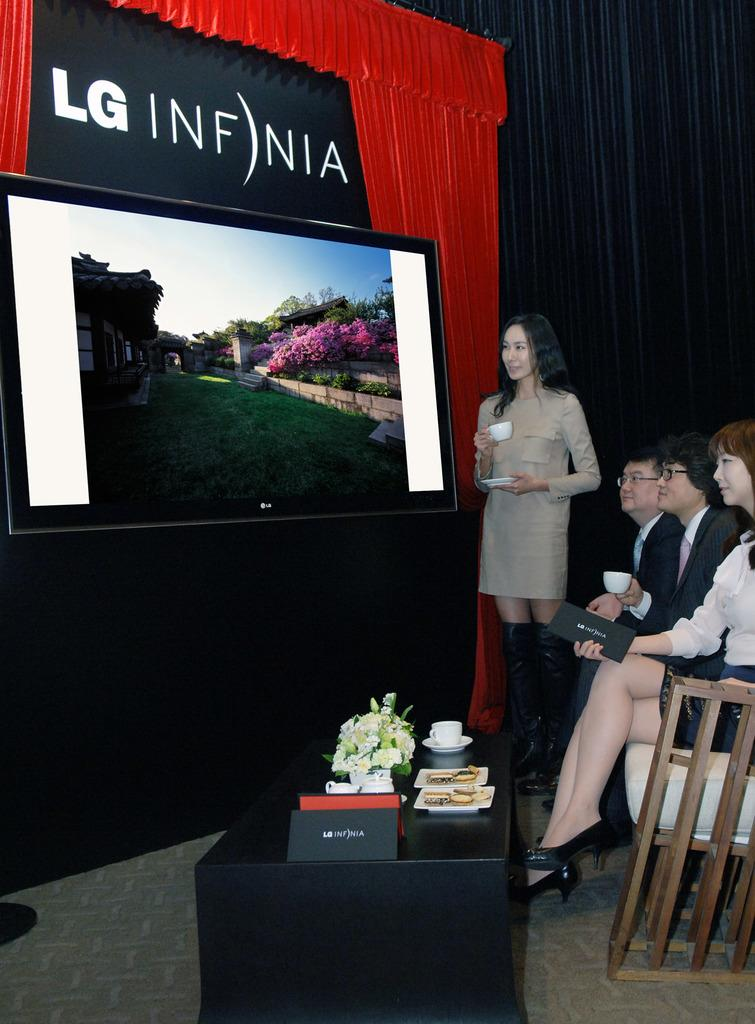<image>
Render a clear and concise summary of the photo. a lady at a presentation with an LG ad near 